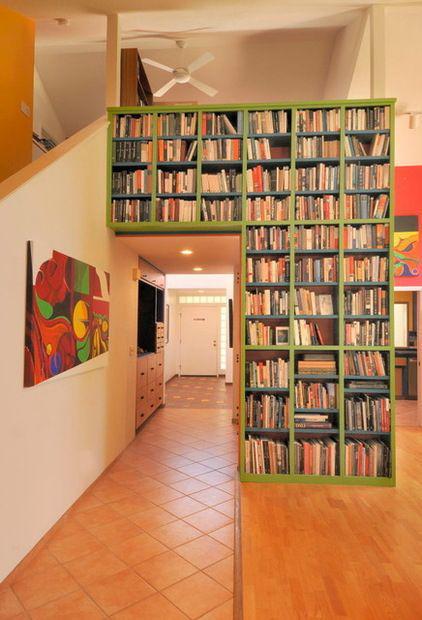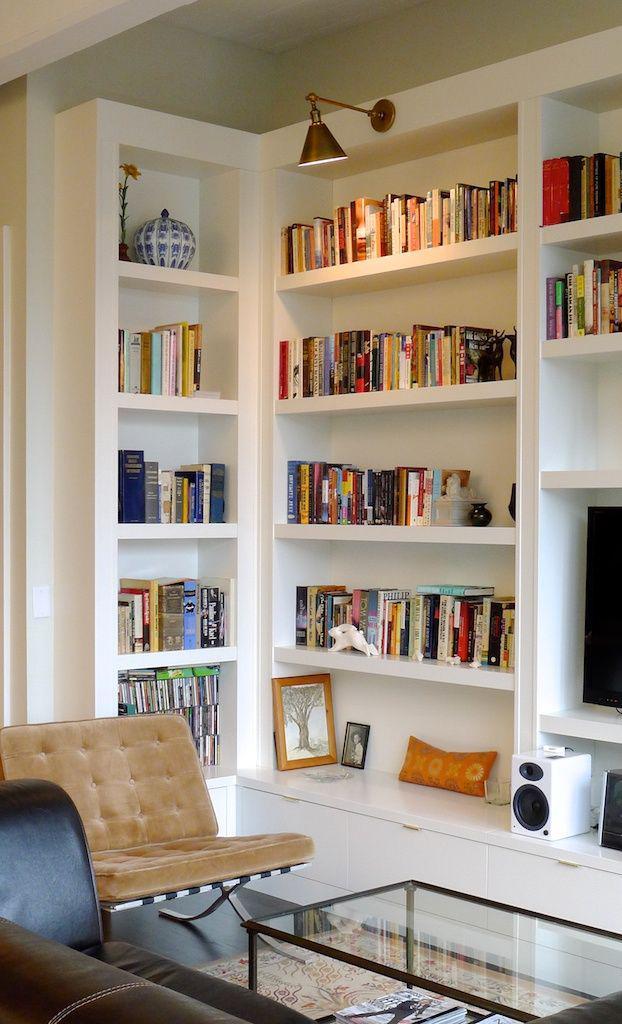The first image is the image on the left, the second image is the image on the right. Analyze the images presented: Is the assertion "In one image, bookcases along a wall flank a fireplace, over which hangs one framed picture." valid? Answer yes or no. No. The first image is the image on the left, the second image is the image on the right. Evaluate the accuracy of this statement regarding the images: "A window is visible behind a seating that is near to a bookcase.". Is it true? Answer yes or no. No. 